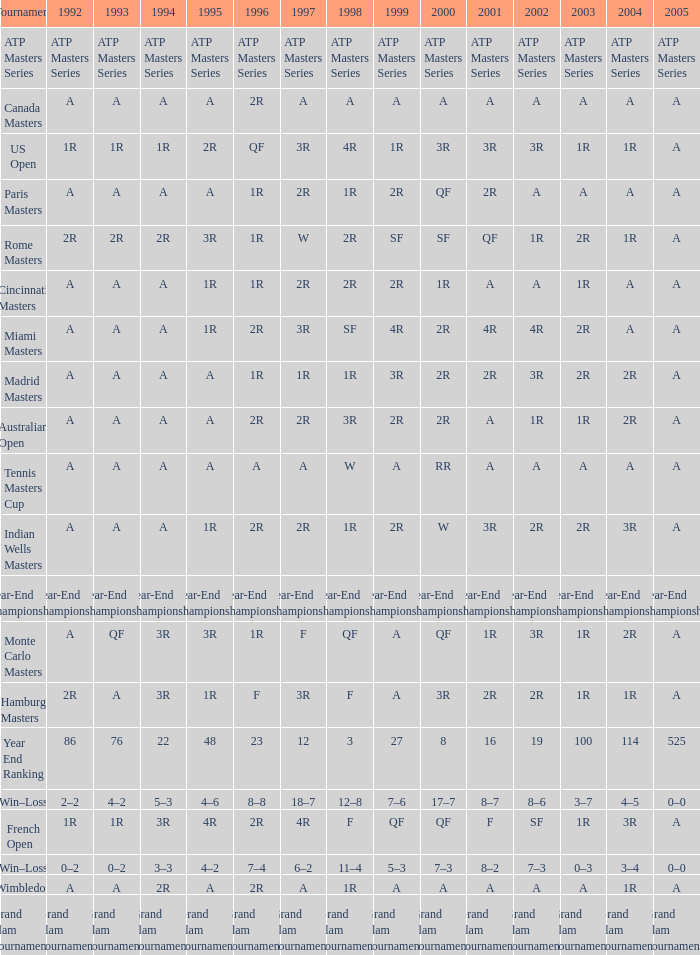What is 2005, when 1998 is "F", and when 2002 is "2R"? A. 